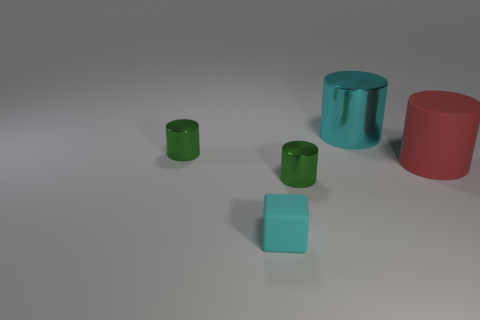How many purple things are either blocks or tiny metallic objects?
Provide a succinct answer. 0. Does the green cylinder behind the big red cylinder have the same material as the tiny block?
Keep it short and to the point. No. What number of other things are the same material as the block?
Ensure brevity in your answer.  1. What is the large cyan cylinder made of?
Provide a succinct answer. Metal. What is the size of the cyan thing that is on the left side of the cyan cylinder?
Your answer should be compact. Small. There is a rubber thing right of the big cyan cylinder; what number of cylinders are on the left side of it?
Provide a succinct answer. 3. Do the small object that is to the left of the cyan matte block and the green metal object that is in front of the matte cylinder have the same shape?
Provide a succinct answer. Yes. What number of matte things are in front of the rubber cylinder and behind the small cyan matte block?
Make the answer very short. 0. Is there a large shiny cylinder of the same color as the large metal object?
Ensure brevity in your answer.  No. There is a large cyan metallic cylinder; are there any cylinders in front of it?
Give a very brief answer. Yes. 